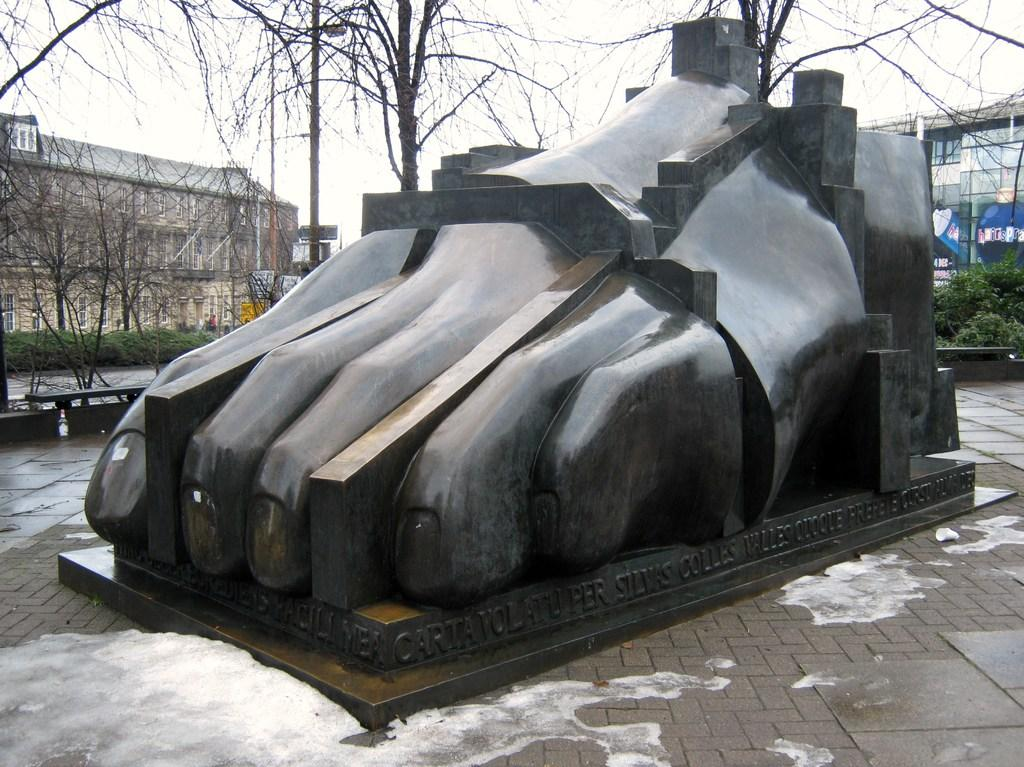What is the main subject in the center of the image? There is a statue in the center of the image. What is located at the bottom of the image? There is a road at the bottom of the image. What can be seen in the background of the image? There are trees, buildings, and the sky visible in the background of the image. What type of jar is being used to store the wealth in the image? There is no jar or wealth present in the image. What type of glass can be seen in the image? There is no glass present in the image. 